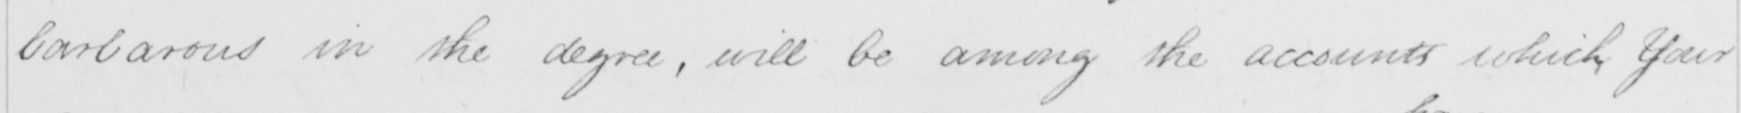Can you read and transcribe this handwriting? barbarous in the degree , will be among the account which Your 